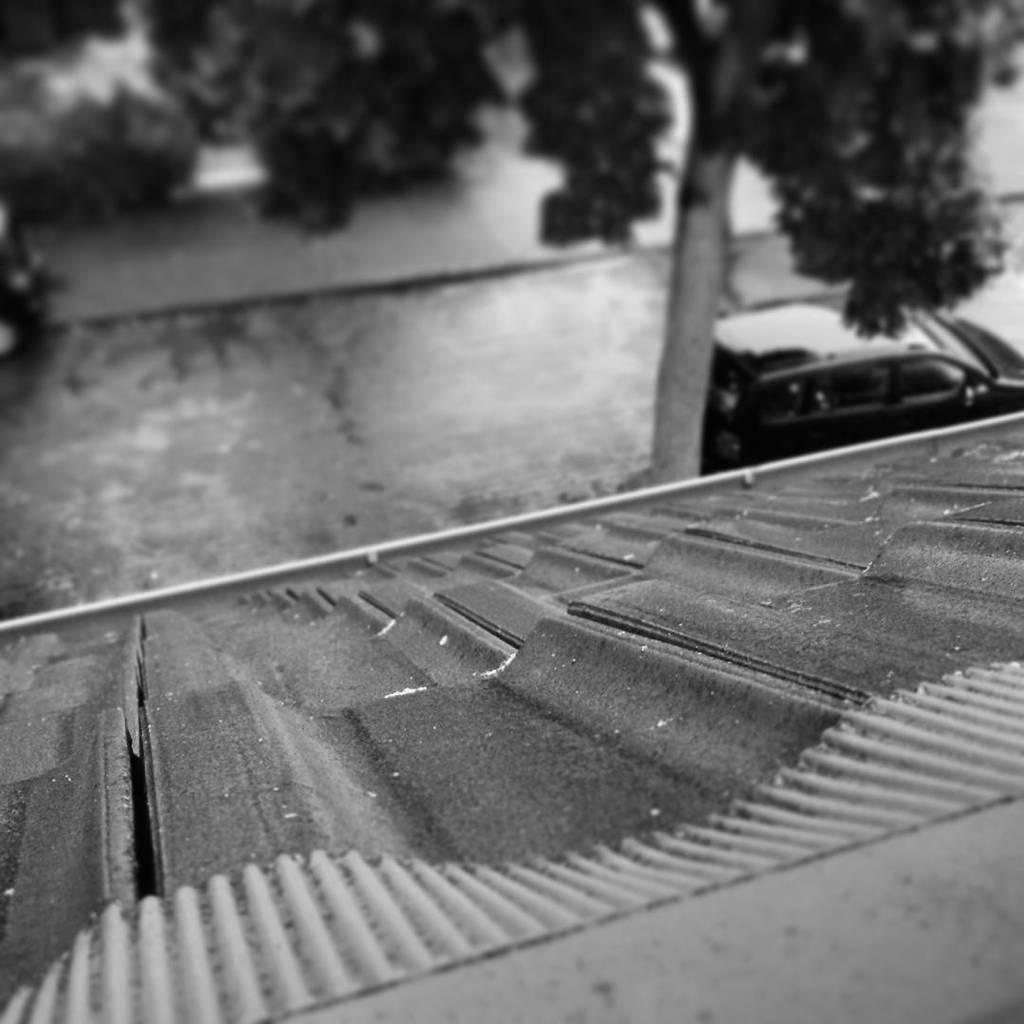Please provide a concise description of this image. This image consists of a roof. In the front, there is a road. To the right, there is a car along with the tree. The image looks like a black and white picture.. 